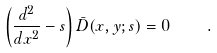Convert formula to latex. <formula><loc_0><loc_0><loc_500><loc_500>\left ( \frac { d ^ { 2 } } { d x ^ { 2 } } - s \right ) \bar { D } ( x , y ; s ) = 0 \quad .</formula> 